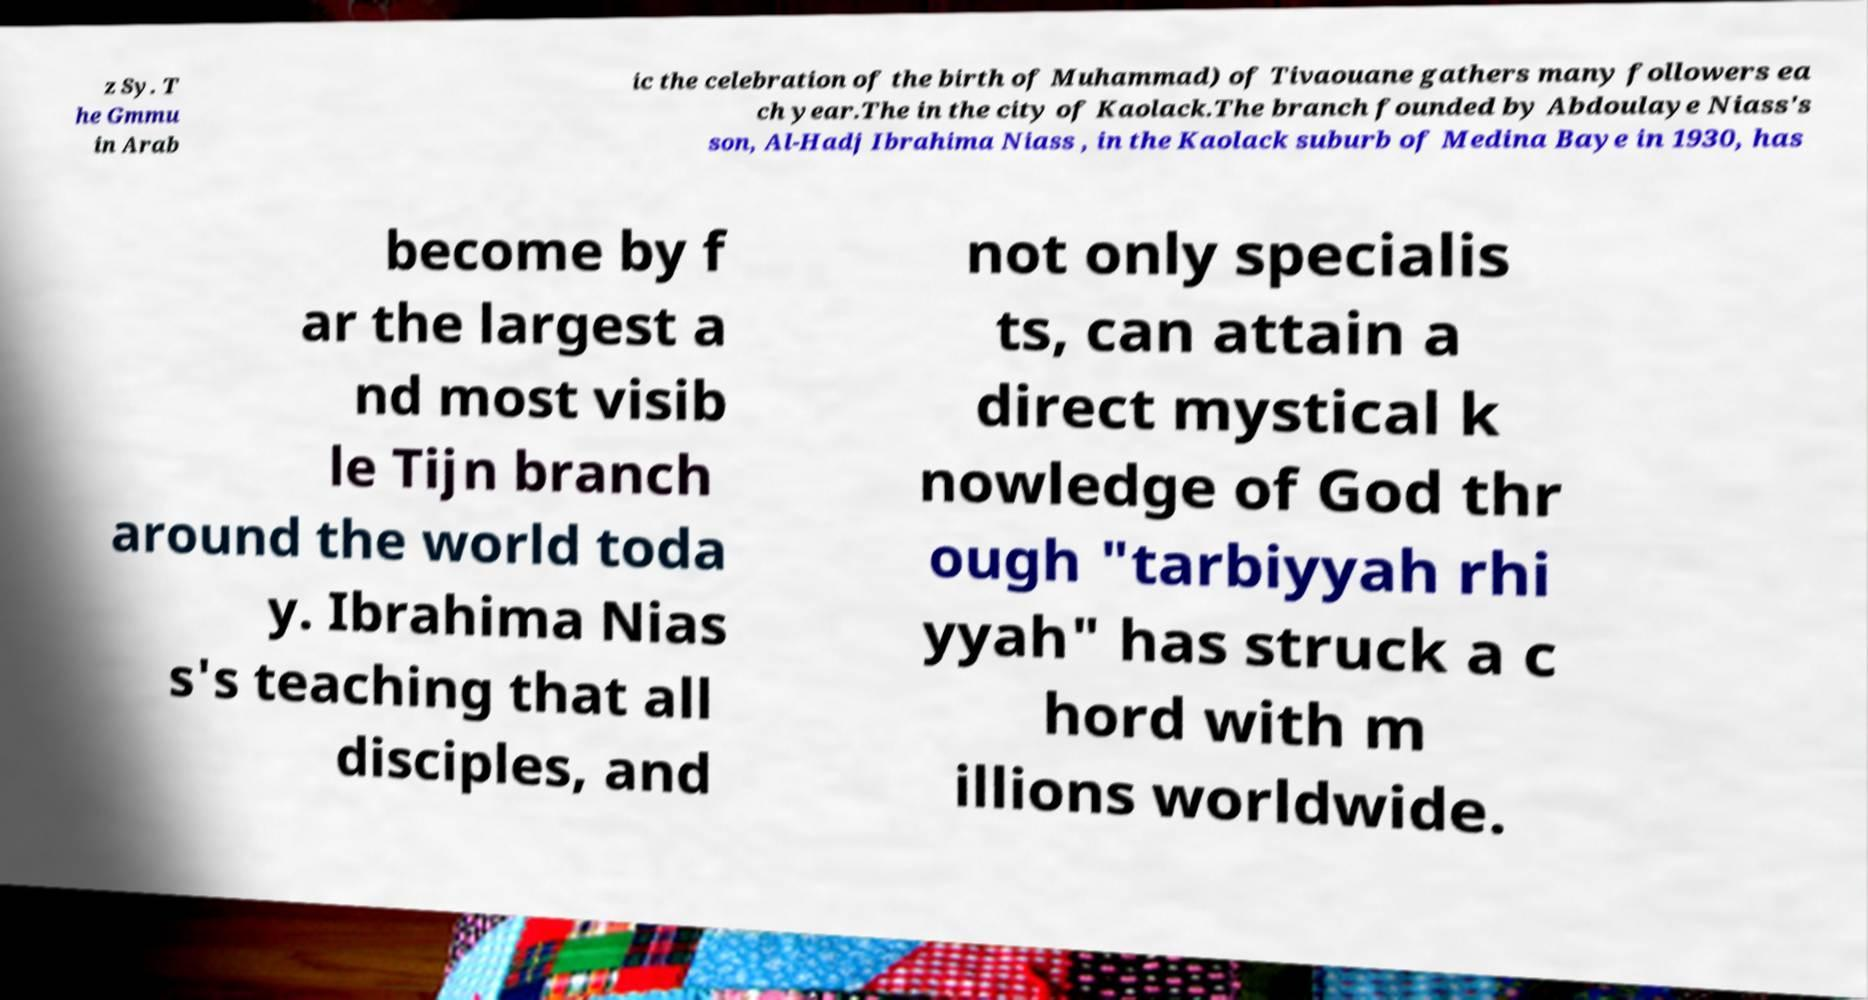Could you assist in decoding the text presented in this image and type it out clearly? z Sy. T he Gmmu in Arab ic the celebration of the birth of Muhammad) of Tivaouane gathers many followers ea ch year.The in the city of Kaolack.The branch founded by Abdoulaye Niass's son, Al-Hadj Ibrahima Niass , in the Kaolack suburb of Medina Baye in 1930, has become by f ar the largest a nd most visib le Tijn branch around the world toda y. Ibrahima Nias s's teaching that all disciples, and not only specialis ts, can attain a direct mystical k nowledge of God thr ough "tarbiyyah rhi yyah" has struck a c hord with m illions worldwide. 